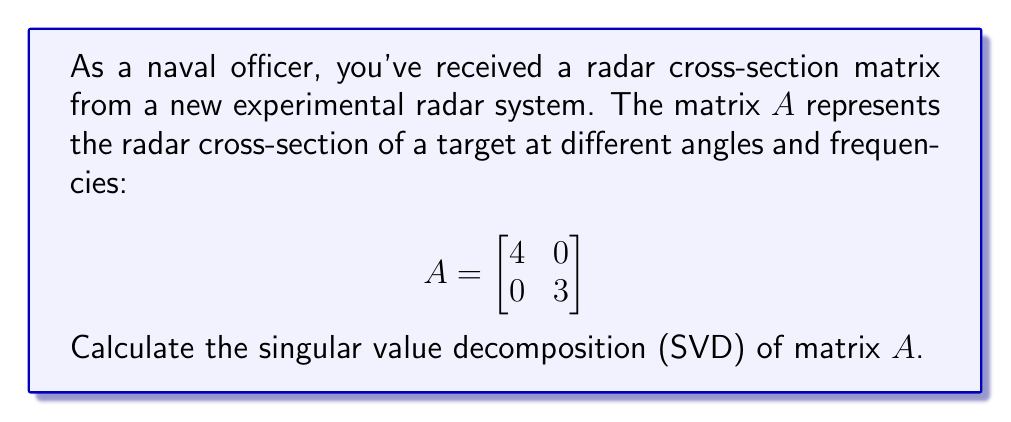Could you help me with this problem? To calculate the singular value decomposition of matrix $A$, we need to find matrices $U$, $\Sigma$, and $V^*$ such that $A = U\Sigma V^*$, where:

1. $U$ and $V$ are unitary matrices
2. $\Sigma$ is a diagonal matrix with non-negative real numbers on the diagonal

Step 1: Since $A$ is already a diagonal matrix, its singular values are the absolute values of its diagonal entries.
$\Sigma = \begin{bmatrix}
4 & 0 \\
0 & 3
\end{bmatrix}$

Step 2: The columns of $U$ are the left singular vectors, which are the eigenvectors of $AA^*$. In this case, $AA^* = A^2$ (since $A$ is real and symmetric):
$AA^* = \begin{bmatrix}
16 & 0 \\
0 & 9
\end{bmatrix}$

The eigenvectors are:
$u_1 = \begin{bmatrix} 1 \\ 0 \end{bmatrix}$ and $u_2 = \begin{bmatrix} 0 \\ 1 \end{bmatrix}$

Thus, $U = \begin{bmatrix}
1 & 0 \\
0 & 1
\end{bmatrix}$

Step 3: The columns of $V$ are the right singular vectors, which are the eigenvectors of $A^*A$. In this case, $A^*A = A^2$ (since $A$ is real and symmetric), so $V = U$.

Therefore, $V = \begin{bmatrix}
1 & 0 \\
0 & 1
\end{bmatrix}$

Step 4: Verify that $A = U\Sigma V^*$:

$$\begin{bmatrix}
1 & 0 \\
0 & 1
\end{bmatrix}
\begin{bmatrix}
4 & 0 \\
0 & 3
\end{bmatrix}
\begin{bmatrix}
1 & 0 \\
0 & 1
\end{bmatrix} =
\begin{bmatrix}
4 & 0 \\
0 & 3
\end{bmatrix} = A$$

The singular value decomposition is complete.
Answer: $A = U\Sigma V^*$, where $U = V = \begin{bmatrix} 1 & 0 \\ 0 & 1 \end{bmatrix}$ and $\Sigma = \begin{bmatrix} 4 & 0 \\ 0 & 3 \end{bmatrix}$ 